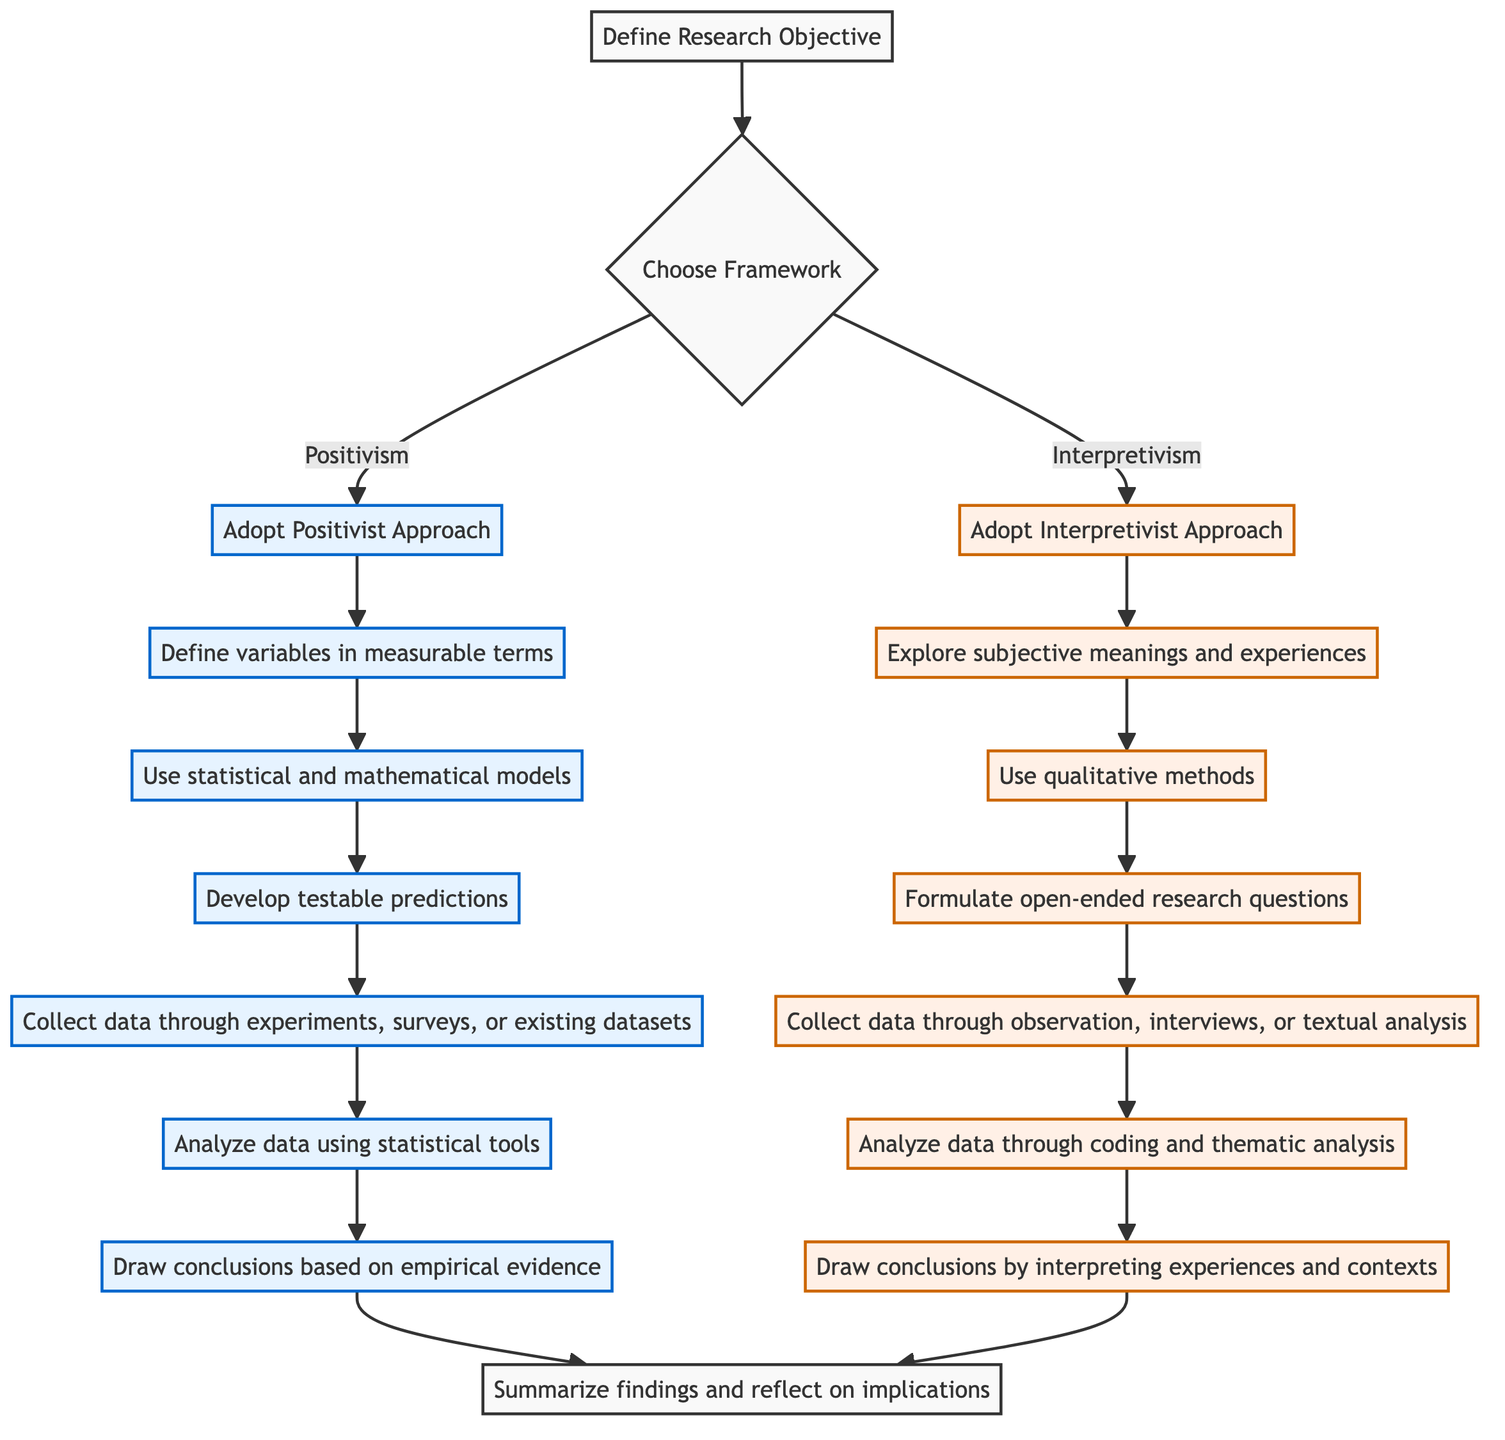What is the first step in the flowchart? The first step in the flowchart is "Define Research Objective." This is indicated as the starting node of the diagram, from which the process flows to the next decision point.
Answer: Define Research Objective How many main approaches are presented in the framework? There are two main approaches presented in the framework: Positivism and Interpretivism. This is shown at the decision node where the framework branches into these two paths.
Answer: 2 What step follows after "Develop Research Questions"? The step that follows "Develop Research Questions" is "Collect data through participant observation, interviews, or textual analysis." This is the next node indicated in the flow from the Interpretivism approach.
Answer: Collect data through participant observation, interviews, or textual analysis Which method is employed to analyze data in the Positivist Approach? The method employed to analyze data in the Positivist Approach is "Analyze data using statistical tools." This is a clear step in the sequence following data collection in the Positivist flow.
Answer: Analyze data using statistical tools What is the last step in the Interpretivist process? The last step in the Interpretivist process is "Draw conclusions by interpreting subjective experiences and social contexts." This is indicated as the final node of the Interpretivist approach before moving on to summarize findings.
Answer: Draw conclusions by interpreting subjective experiences and social contexts Which step comes after "Understand Subjective Meaning" in the Interpretivist approach? The step that comes after "Understand Subjective Meaning" is "Use qualitative methods." This is clearly shown as the next node in the flow of the Interpretivist approach following the exploration of subjective meanings.
Answer: Use qualitative methods What connects the end of the Positivist approach to the end of the Interpretivist approach? Both approaches lead to the same final step, which is "Summarize findings and reflect on implications." This is shown in the diagram as both paths converge to this concluding step.
Answer: Summarize findings and reflect on implications How does the flowchart handle the research objective? The flowchart initiates the process by addressing and defining the research objective at the start, which directs subsequent decision-making for selecting a philosophical framework.
Answer: Define Research Objective What is the primary focus of the Interpretivist approach? The primary focus of the Interpretivist approach is to "Explore the subjective meanings and experiences of participants." This is explicitly stated in the description of the first step in the Interpretivist pathway.
Answer: Explore the subjective meanings and experiences of participants 